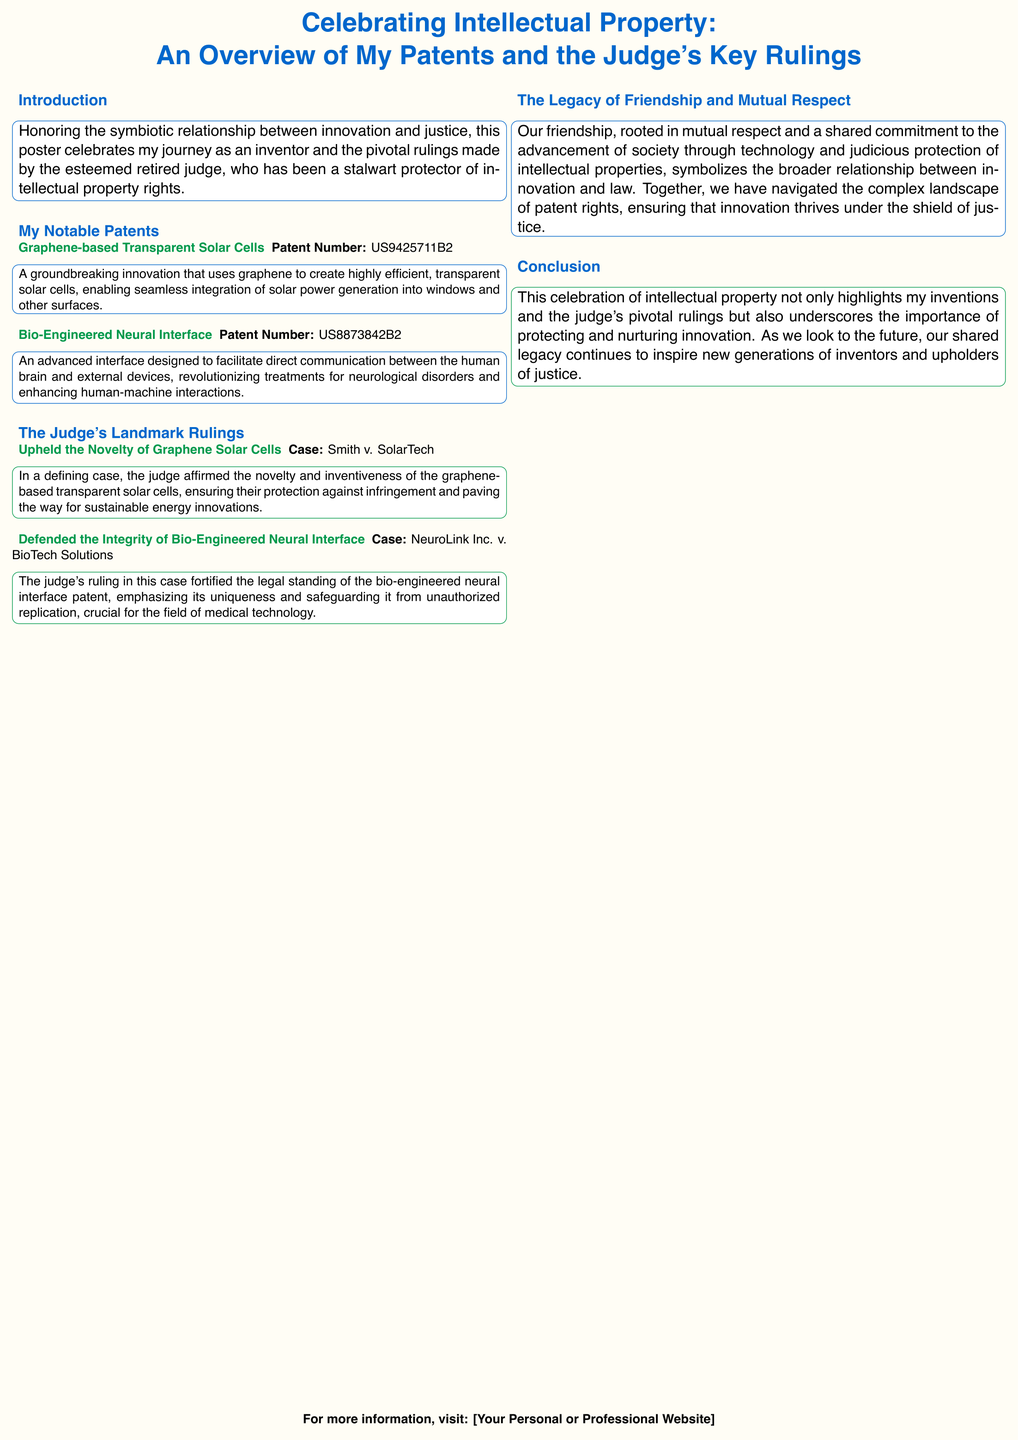What is the main focus of the poster? The poster emphasizes the relationship between innovation and justice in intellectual property rights, highlighting the inventor's patents and the judge's rulings.
Answer: Innovation and justice What is the patent number for the Graphene-based Transparent Solar Cells? The patent number is stated in the section detailing the graphene solar cells.
Answer: US9425711B2 What is the case associated with the graphene solar cells? The specific case that highlights the ruling on graphene solar cells is mentioned in the judge's landmark rulings section.
Answer: Smith v. SolarTech What key feature does the Bio-Engineered Neural Interface provide? The function of the neural interface is described with regard to its ability to facilitate communication between the human brain and external devices.
Answer: Direct communication What does the judge's ruling in NeuroLink Inc. v. BioTech Solutions emphasize? The ruling's significance is explained in terms of its focus on the uniqueness and protection of the bio-engineered neural interface patent.
Answer: Uniqueness What color represents the inventor in the poster? The poster uses specific colors to represent different themes, and the inventor is associated with a particular color.
Answer: Inventor blue Which invention is described as enabling solar power generation integration? The invention highlighted for its potential to integrate solar power generation is specifically named in the patents section.
Answer: Graphene-based Transparent Solar Cells What does the concluding section of the poster emphasize? The conclusion reflects on the significance of protecting innovation and the shared legacy between the inventor and the judge.
Answer: Protecting innovation 